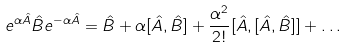<formula> <loc_0><loc_0><loc_500><loc_500>e ^ { \alpha \hat { A } } \hat { B } e ^ { - \alpha \hat { A } } = \hat { B } + \alpha [ \hat { A } , \hat { B } ] + \frac { \alpha ^ { 2 } } { 2 ! } [ \hat { A } , [ \hat { A } , \hat { B } ] ] + \dots</formula> 